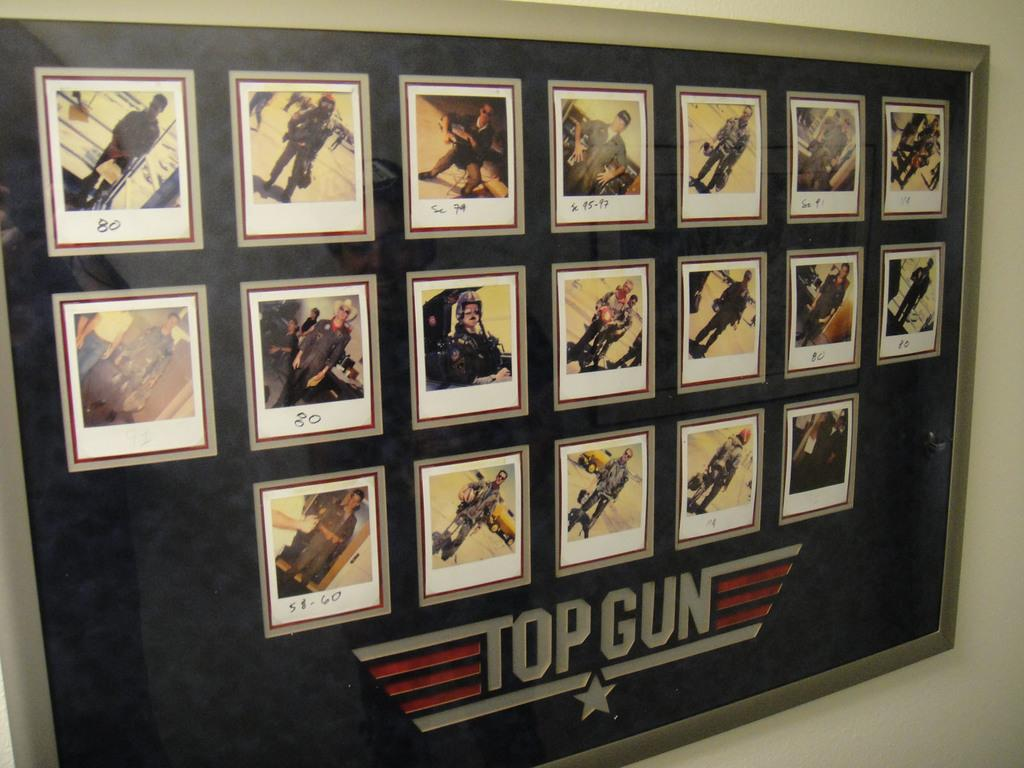<image>
Write a terse but informative summary of the picture. A framed set of poloroid pictures of airmen with the words Top Gun on it. 